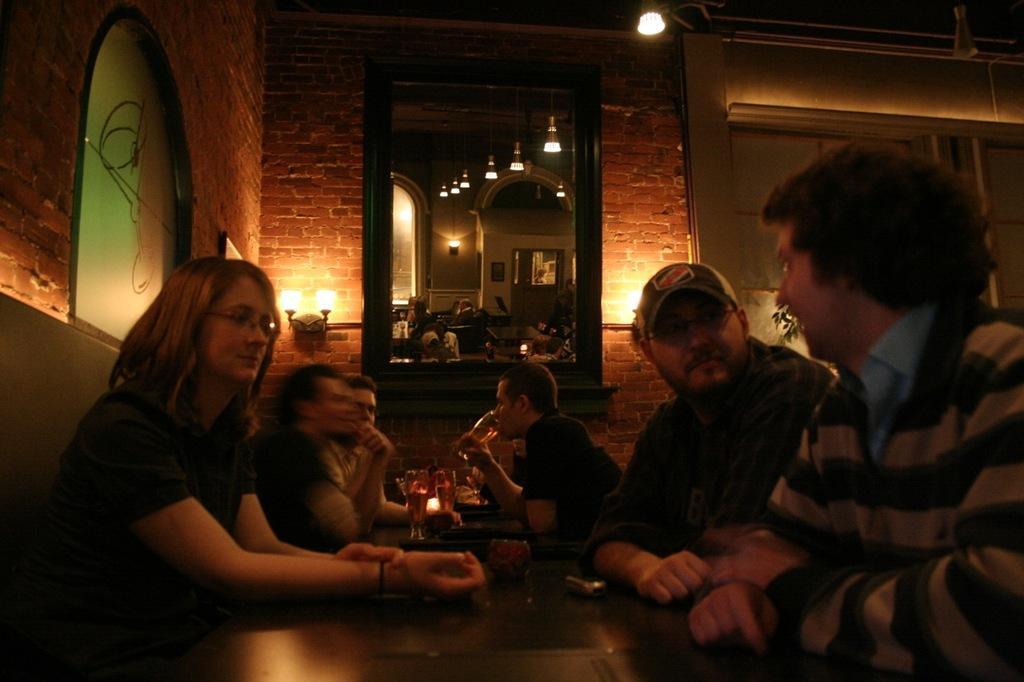Please provide a concise description of this image. There are people sitting and this man holding glass. We can see glasses and objects on tables. In the background we can see painting on glass, mirror, lights and wall, in this mirror we can see lights, wall and tables. 